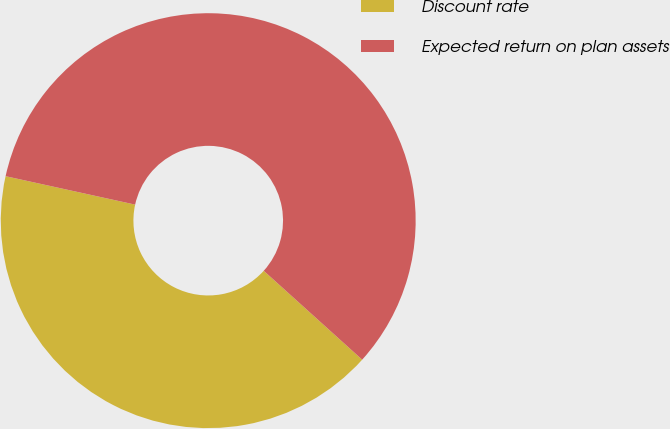Convert chart. <chart><loc_0><loc_0><loc_500><loc_500><pie_chart><fcel>Discount rate<fcel>Expected return on plan assets<nl><fcel>41.75%<fcel>58.25%<nl></chart> 